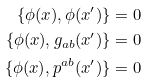<formula> <loc_0><loc_0><loc_500><loc_500>\{ \phi ( x ) , \phi ( x ^ { \prime } ) \} & = 0 \\ \{ \phi ( x ) , g _ { a b } ( x ^ { \prime } ) \} & = 0 \\ \{ \phi ( x ) , p ^ { a b } ( x ^ { \prime } ) \} & = 0</formula> 